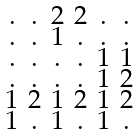<formula> <loc_0><loc_0><loc_500><loc_500>\begin{smallmatrix} . & . & 2 & 2 & . & . \\ . & . & 1 & . & . & . \\ . & . & . & . & 1 & 1 \\ . & . & . & . & 1 & 2 \\ 1 & 2 & 1 & 2 & 1 & 2 \\ 1 & . & 1 & . & 1 & . \end{smallmatrix}</formula> 